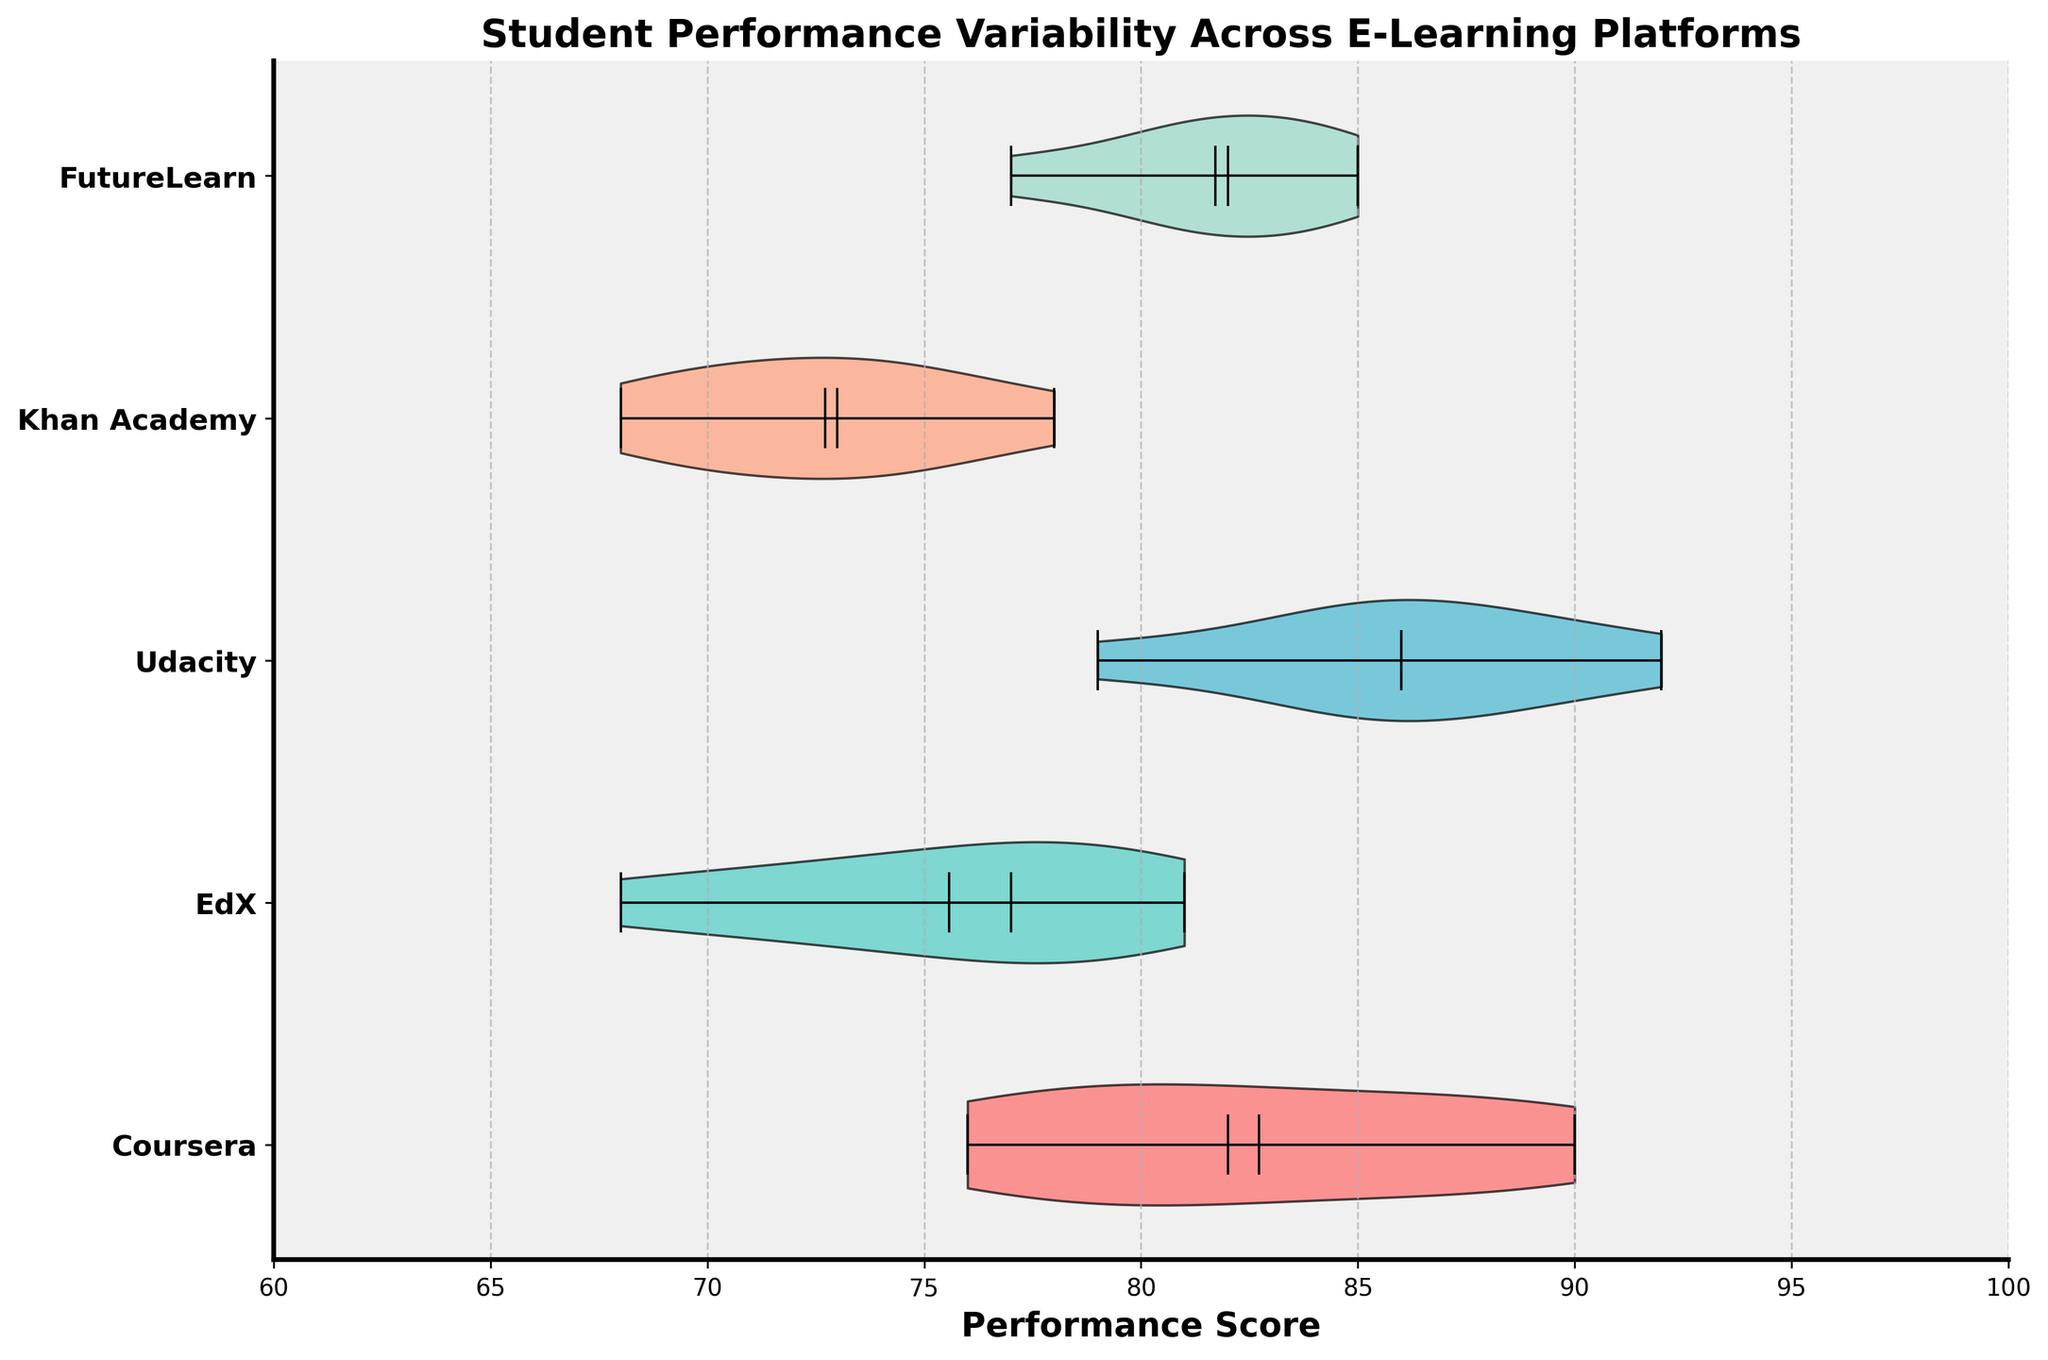What is the title of the plot? The title is usually found at the top of a plot and is used to describe what the plot is about.
Answer: Student Performance Variability Across E-Learning Platforms Which platform shows the highest mean performance? The mean performance can be identified by the white dot within each violin plot. The highest mean performance is indicated by the dot on the far right.
Answer: Udacity What is the performance range for FutureLearn? The range of performance scores is depicted by the ends of the violin plot. For FutureLearn, it spans from the minimum to the maximum data point.
Answer: 77 to 85 Which platform has the lowest median performance score? The median is shown by the horizontal line inside each violin plot. The platform with the lowest median score will have the line closest to the left.
Answer: Khan Academy How does the variability of performance scores for Coursera compare to that of EdX? Variability can be assessed by the width and spread of the violin plots. Coursera's plot appears wider and more spread out than EdX's, indicating higher performance variability.
Answer: Coursera has higher variability What is the median performance score for Udacity? The median, represented by the middle horizontal line within the violin plot, shows the central value of performance scores.
Answer: 86 How does the interquartile range (IQR) of EdX's performance scores compare to Khan Academy? The IQR is shown by the thicker middle part of the violin. The wider the middle section, the larger the IQR. Comparing their widths helps determine which platform has a greater IQR.
Answer: EdX has a larger IQR Which platforms have overlapping performance ranges? Overlapping ranges can be identified by comparing the extents of the violin plots horizontally. If the ranges overlap along the x-axis, the performance ranges are overlapping.
Answer: Coursera and FutureLearn; EdX and Khan Academy What color is used for the Coursera platform in the plot? Each platform is color-coded. Identifying Coursera's color helps in distinguishing its data. Coursera is the first platform from the top.
Answer: Red Which platform exhibits the least performance variability? The platform with the narrowest and least spread-out violin plot indicates the least variability in performance scores.
Answer: Khan Academy 